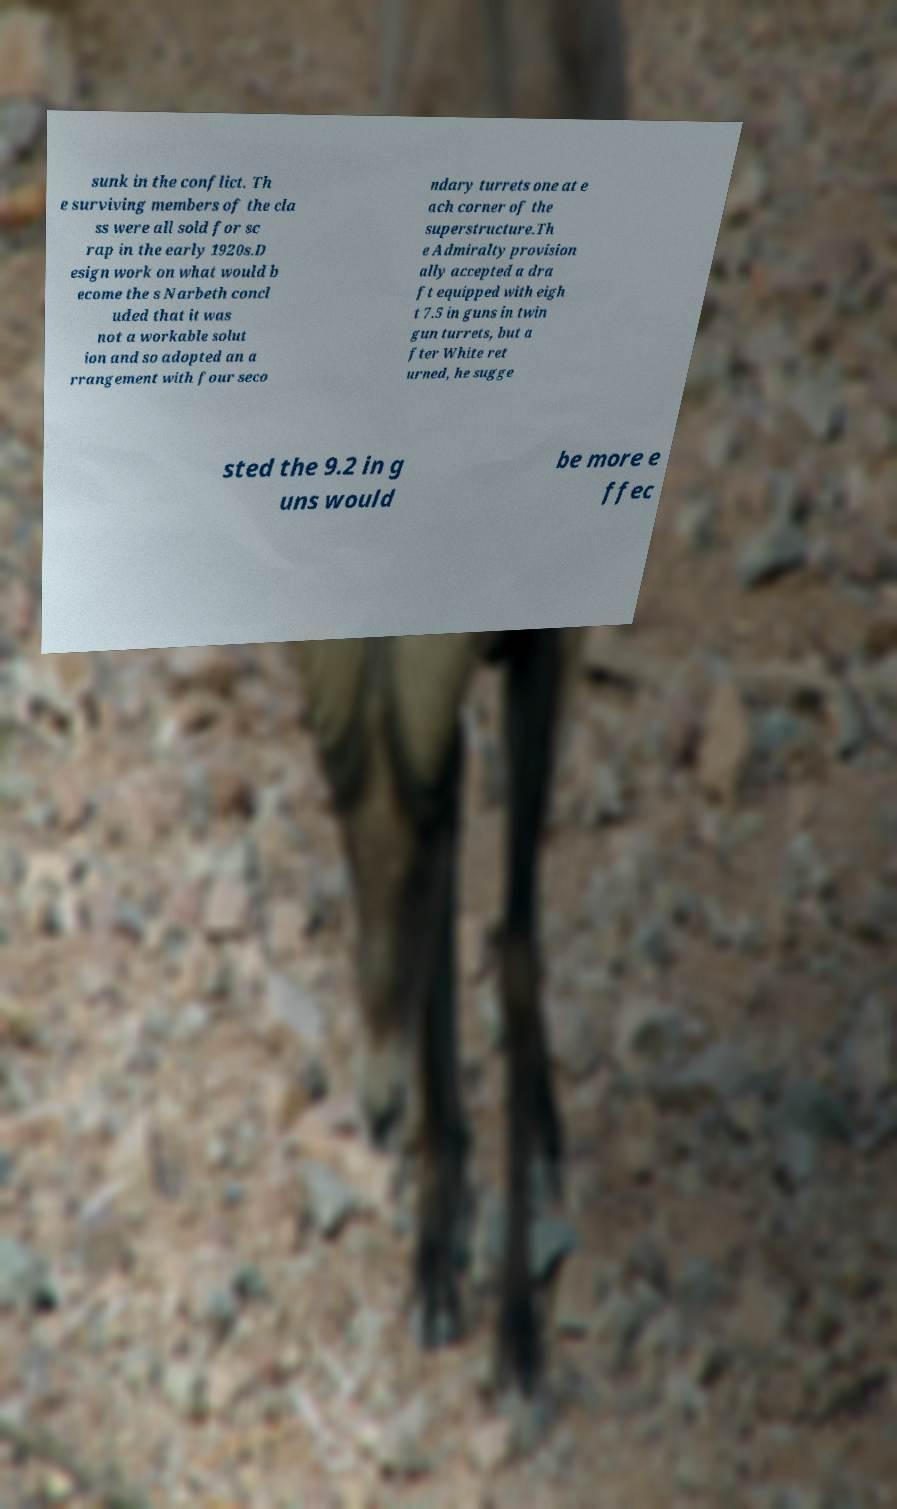There's text embedded in this image that I need extracted. Can you transcribe it verbatim? sunk in the conflict. Th e surviving members of the cla ss were all sold for sc rap in the early 1920s.D esign work on what would b ecome the s Narbeth concl uded that it was not a workable solut ion and so adopted an a rrangement with four seco ndary turrets one at e ach corner of the superstructure.Th e Admiralty provision ally accepted a dra ft equipped with eigh t 7.5 in guns in twin gun turrets, but a fter White ret urned, he sugge sted the 9.2 in g uns would be more e ffec 